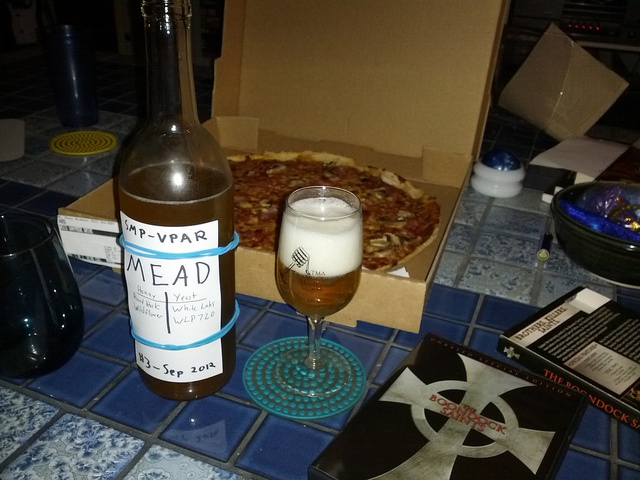Describe the objects in this image and their specific colors. I can see dining table in black, navy, gray, and blue tones, bottle in black, white, and darkgray tones, book in black and gray tones, pizza in black, maroon, and olive tones, and wine glass in black, beige, maroon, lightgray, and teal tones in this image. 